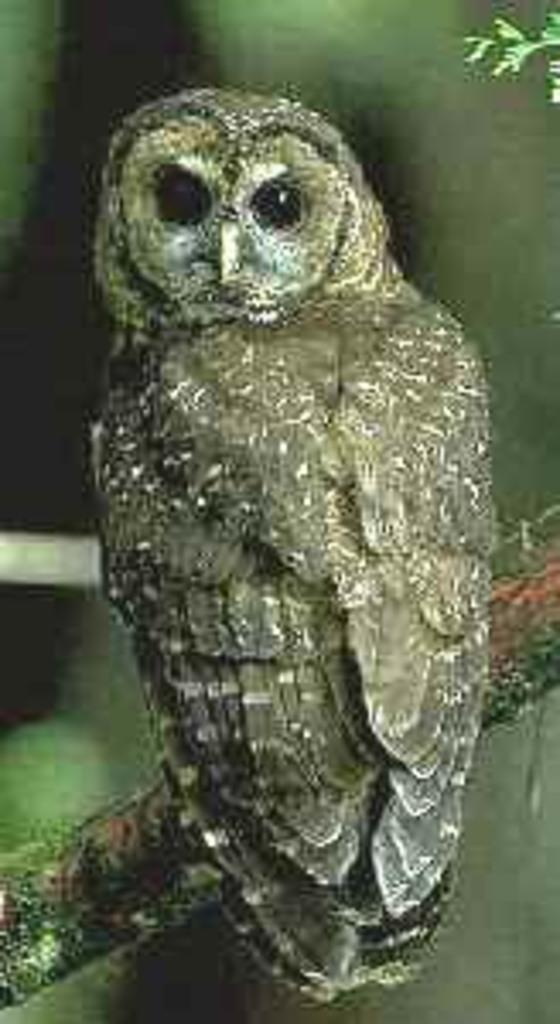What animal is the main subject of the picture? There is an owl in the picture. Where is the owl located in the picture? The owl is in the middle of the picture. What type of throne is the owl sitting on in the image? There is no throne present in the image; the owl is simply in the middle of the picture. 